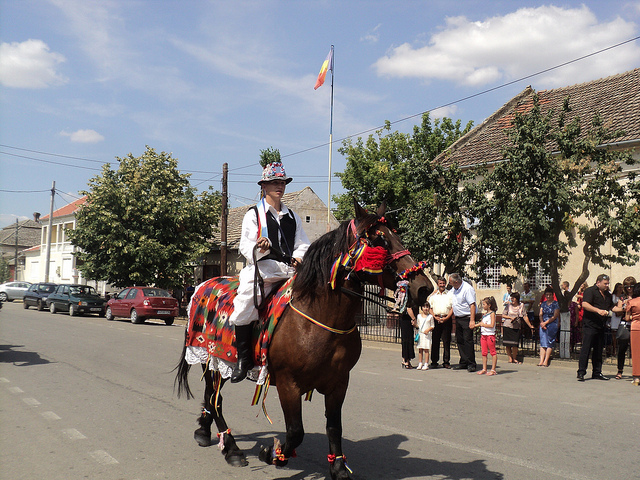<image>What is the make of the red car? I am not sure about the make of the red car. It could be Chevrolet, Ford, or Toyota. What is the make of the red car? I don't know what is the make of the red car. It can be Chevrolet, Ford, Toyota or unknown. 